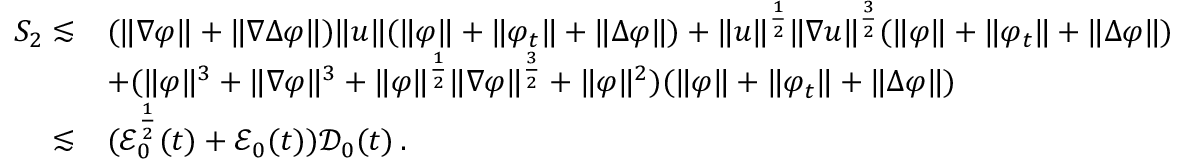<formula> <loc_0><loc_0><loc_500><loc_500>\begin{array} { r l } { S _ { 2 } \lesssim } & { ( \| \nabla \varphi \| + \| \nabla \Delta \varphi \| ) \| u \| ( \| \varphi \| + \| \varphi _ { t } \| + \| \Delta \varphi \| ) + \| u \| ^ { \frac { 1 } { 2 } } \| \nabla u \| ^ { \frac { 3 } { 2 } } ( \| \varphi \| + \| \varphi _ { t } \| + \| \Delta \varphi \| ) } \\ & { + ( \| \varphi \| ^ { 3 } + \| \nabla \varphi \| ^ { 3 } + \| \varphi \| ^ { \frac { 1 } { 2 } } \| \nabla \varphi \| ^ { \frac { 3 } { 2 } } + \| \varphi \| ^ { 2 } ) ( \| \varphi \| + \| \varphi _ { t } \| + \| \Delta \varphi \| ) } \\ { \lesssim } & { ( \mathcal { E } _ { 0 } ^ { \frac { 1 } { 2 } } ( t ) + \mathcal { E } _ { 0 } ( t ) ) \mathcal { D } _ { 0 } ( t ) \, . } \end{array}</formula> 